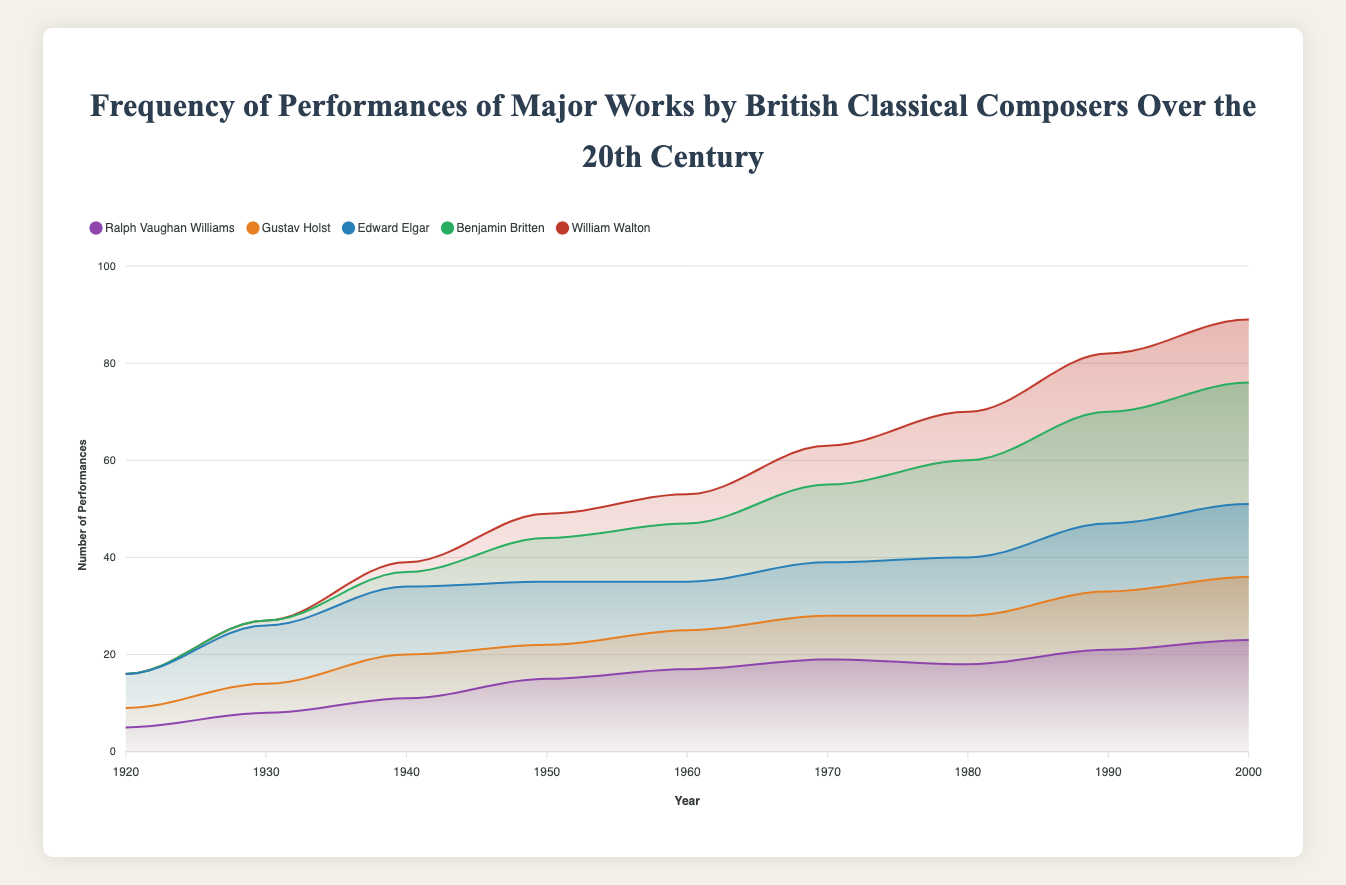What is the title of the chart? The title is usually displayed at the top of the chart. In this chart, the title is "Frequency of Performances of Major Works by British Classical Composers Over the 20th Century."
Answer: Frequency of Performances of Major Works by British Classical Composers Over the 20th Century What is the trend for performances of Ralph Vaughan Williams' works from 1920 to 2000? To understand the trend, examine the data points corresponding to Ralph Vaughan Williams for each year. The number of performances generally increases over time.
Answer: Increasing trend Which composer had the highest number of performances in 1930? Look at the data values for the year 1930. Edward Elgar had 12 performances, which is the highest.
Answer: Edward Elgar In 1950, how many more performances did Ralph Vaughan Williams have compared to Benjamin Britten? Subtract the number of performances of Benjamin Britten from Ralph Vaughan Williams for 1950: 15 - 9 = 6.
Answer: 6 Which composer showed the most dramatic increase in performances between 1940 and 1980? Calculate the difference in performances between 1940 and 1980 for each composer. Benjamin Britten's performances increased from 3 to 20, a difference of 17, which is the largest.
Answer: Benjamin Britten How did the total number of performances for all composers change from 1920 to 2000? Sum the performances of all composers for both years and compare: (5 + 4 + 7 + 0 + 0) in 1920 = 16, and (23 + 13 + 15 + 25 + 13) in 2000 = 89. There is a significant increase.
Answer: Increased significantly What pattern can be observed in Gustav Holst's performances between 1920 and 2000? Reviewing the data, Gustav Holst’s performances show a steady but moderate increase over time.
Answer: Steady increase Was there any year in which William Walton's works were performed more than Ralph Vaughan Williams'? Compare the performances of William Walton and Ralph Vaughan Williams for all years. Ralph Vaughan Williams’ performances were consistently higher.
Answer: No In which decade did Benjamin Britten surpass Edward Elgar in the number of performances? Compare the decade-wise data for both composers. Benjamin Britten surpassed Edward Elgar in 1950 and maintained a higher frequency thereafter.
Answer: 1950s What is the total number of performances of Edward Elgar's works in the 20th century according to this data? Sum up the performances for Edward Elgar across all years: 7 + 12 + 14 + 13 + 10 + 11 + 12 + 14 + 15 = 98.
Answer: 98 